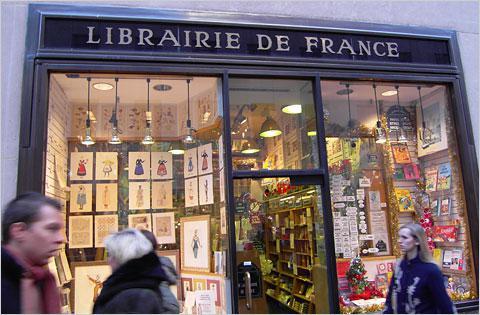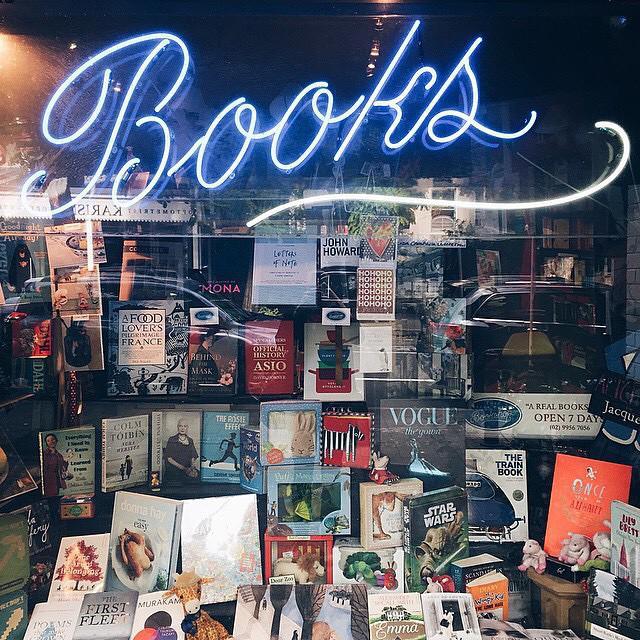The first image is the image on the left, the second image is the image on the right. For the images displayed, is the sentence "In at least one image there is a single book display in the window with at least one neon sign hanging about the books." factually correct? Answer yes or no. Yes. The first image is the image on the left, the second image is the image on the right. For the images shown, is this caption "The bookshop in the right image has an informational fold out sign out front." true? Answer yes or no. No. 